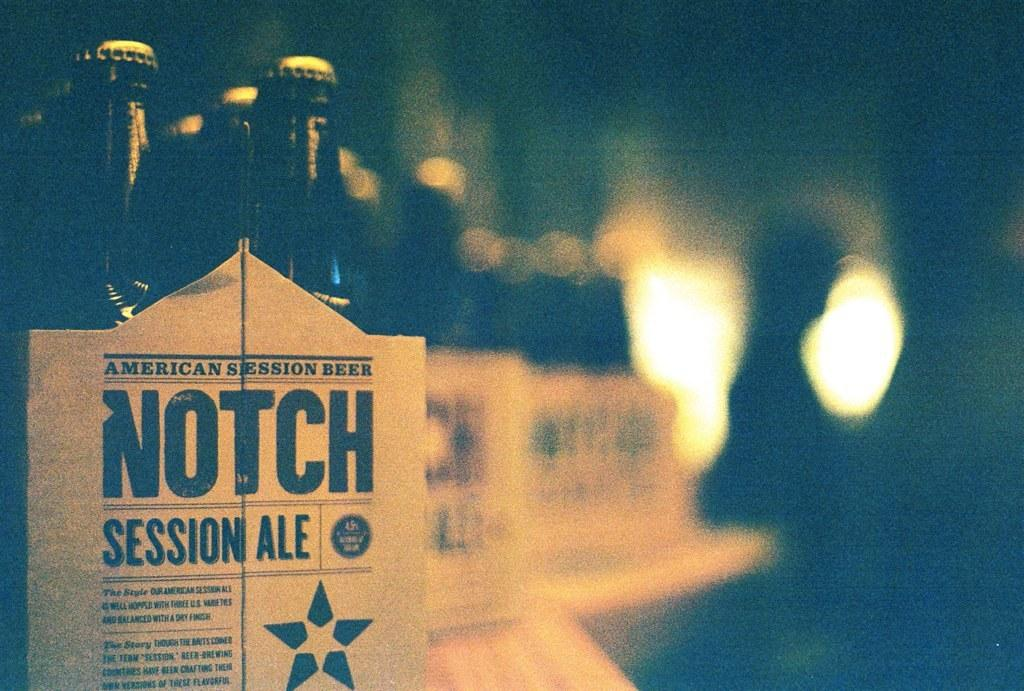Provide a one-sentence caption for the provided image. Packages of Notch Session Ale Beer Bottles on a line. 